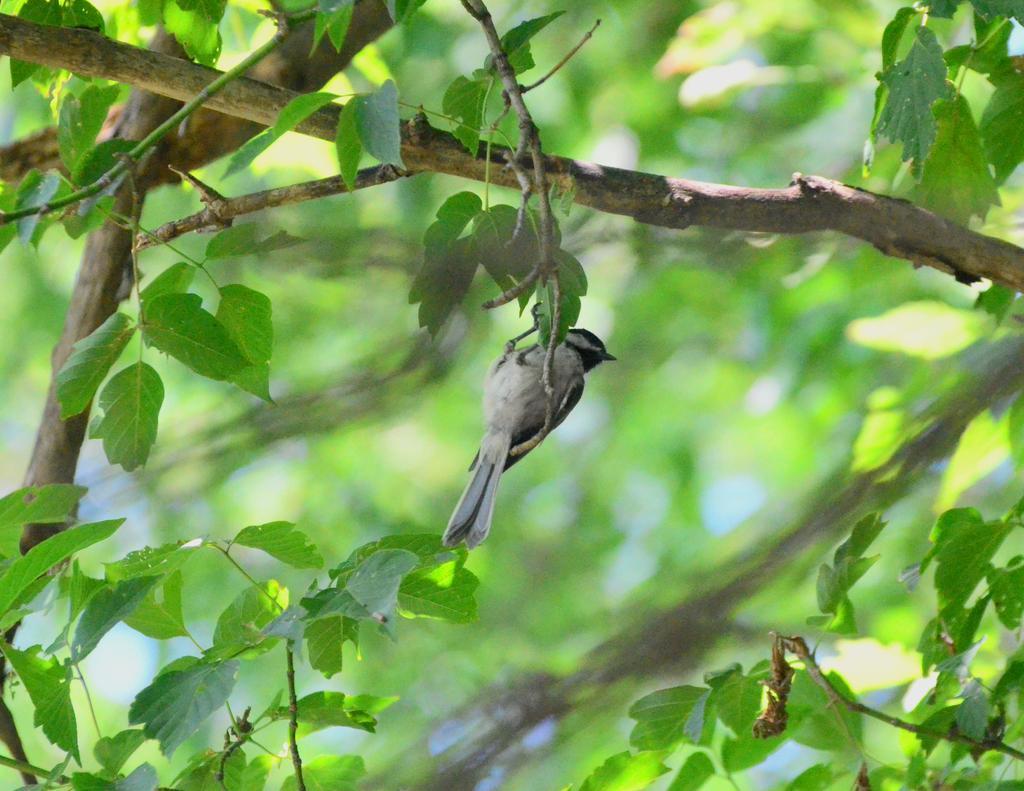Can you describe this image briefly? In this picture we can observe a bird on the branch of a tree. We can observe some leaves which are in green color. The background is completely blurred. 